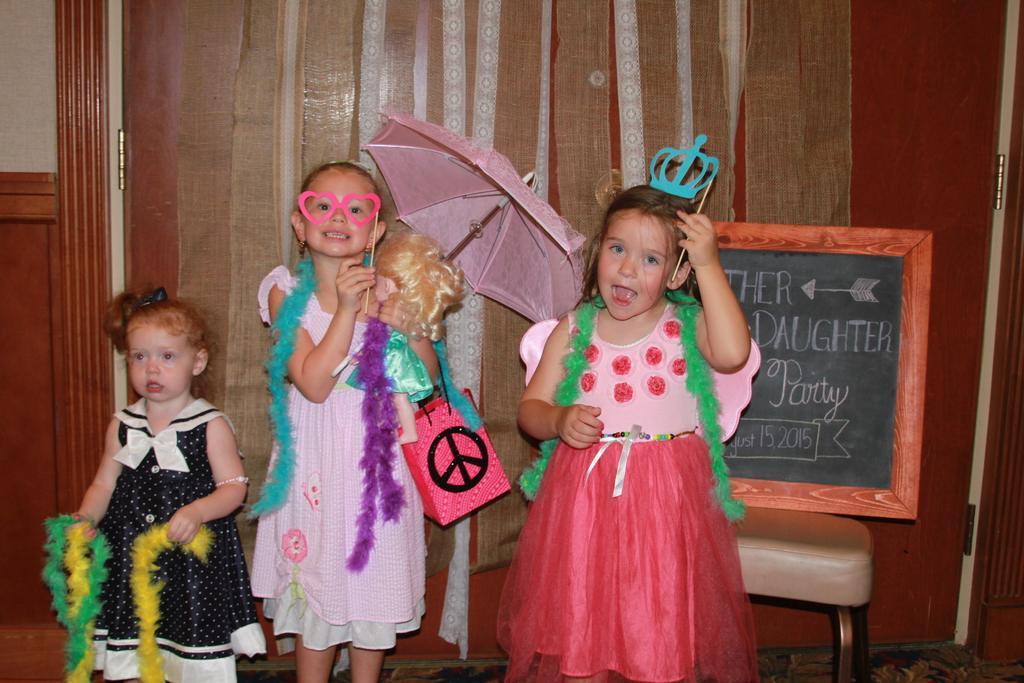Can you describe this image briefly? In this picture we can see three girls, bag, umbrella, board, stool, party objects, curtains and some objects and in the background we can see the wall. 